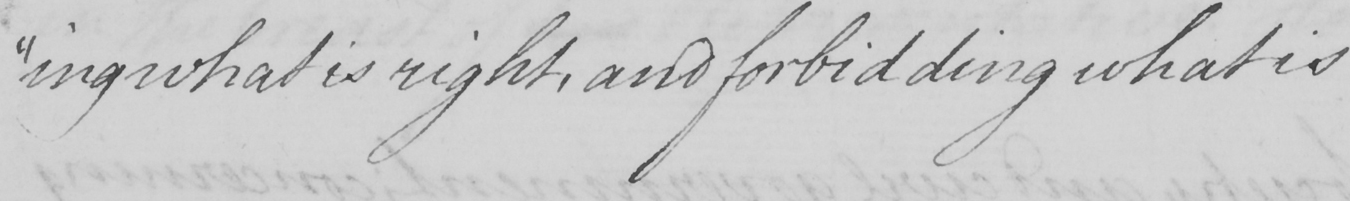Can you read and transcribe this handwriting? "ing what is right, and forbidding what is 